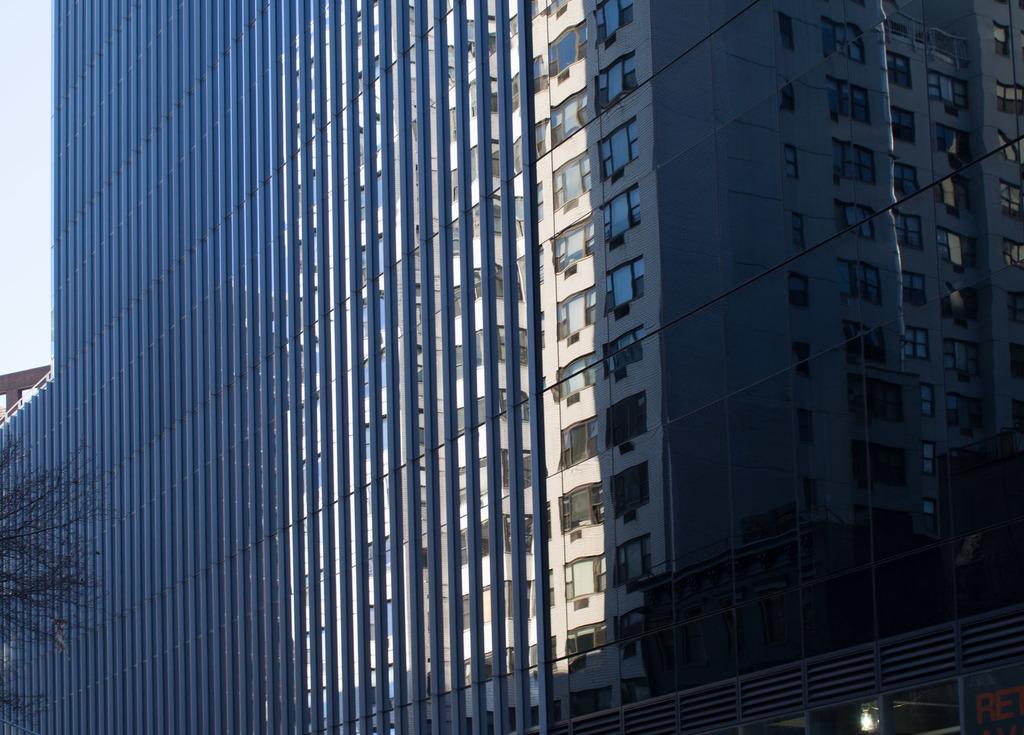Can you describe this image briefly? In this picture, there is a building with windows. Towards the bottom left, there is a tree. 